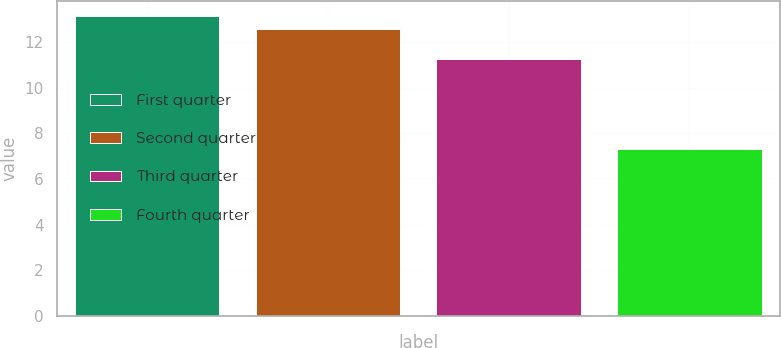<chart> <loc_0><loc_0><loc_500><loc_500><bar_chart><fcel>First quarter<fcel>Second quarter<fcel>Third quarter<fcel>Fourth quarter<nl><fcel>13.17<fcel>12.6<fcel>11.27<fcel>7.3<nl></chart> 